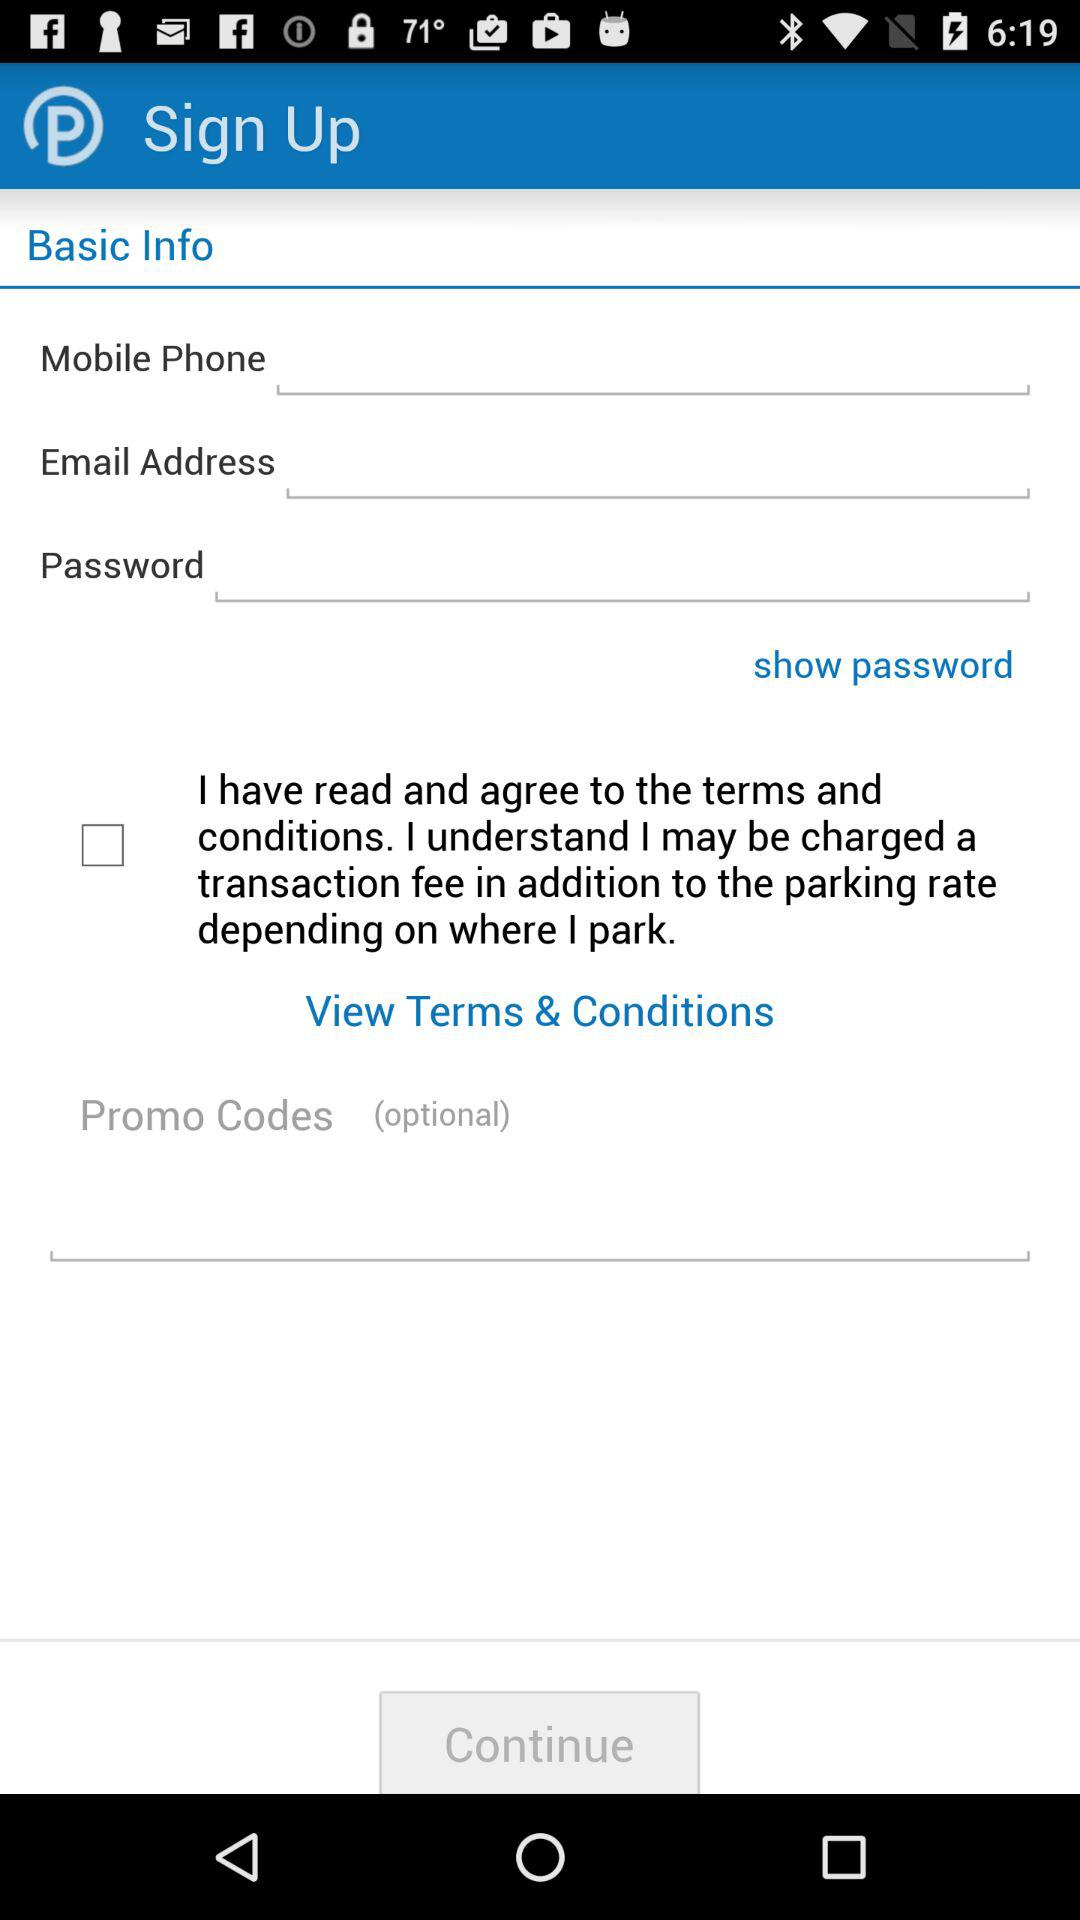How many text inputs are there for the user to fill out?
Answer the question using a single word or phrase. 3 